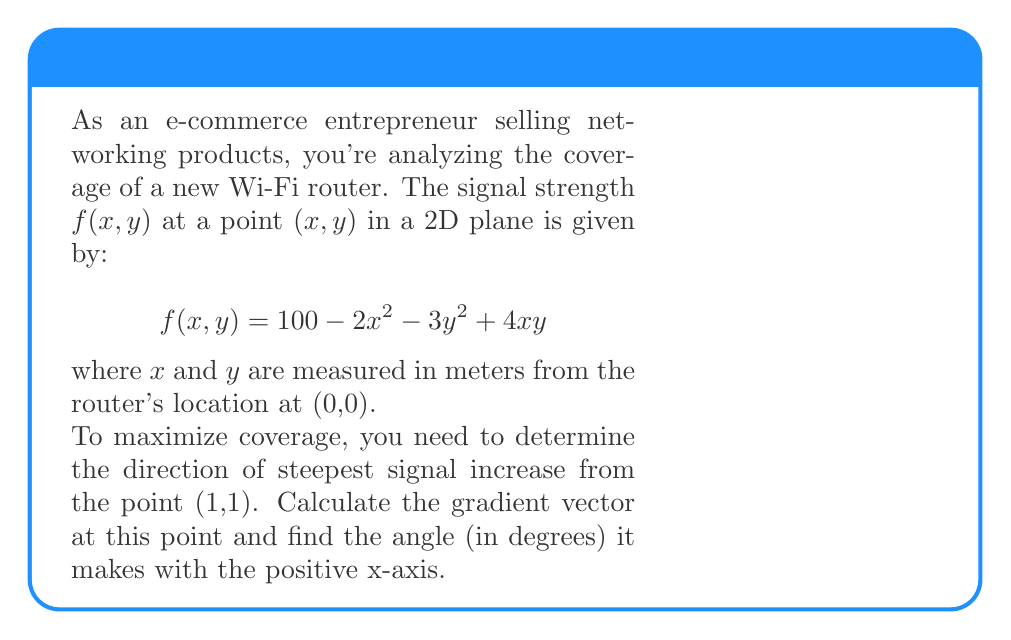Teach me how to tackle this problem. Let's approach this step-by-step:

1) The gradient vector is given by:
   $$\nabla f(x,y) = \left(\frac{\partial f}{\partial x}, \frac{\partial f}{\partial y}\right)$$

2) Calculate the partial derivatives:
   $$\frac{\partial f}{\partial x} = -4x + 4y$$
   $$\frac{\partial f}{\partial y} = -6y + 4x$$

3) The gradient vector at point (1,1) is:
   $$\nabla f(1,1) = (-4(1) + 4(1), -6(1) + 4(1)) = (0, -2)$$

4) To find the angle $\theta$ with the positive x-axis, we use the arctangent function:
   $$\theta = \arctan\left(\frac{y}{x}\right)$$

   Here, $x = 0$ and $y = -2$

5) Since $x = 0$, we're dealing with a vertical vector. The angle is:
   $$\theta = \arctan(\infty) = 90°$$

6) However, since the y-component is negative, we need to add 180° to get the correct direction:
   $$\theta = 90° + 180° = 270°$$

Therefore, the gradient vector points in the direction 270° from the positive x-axis, or equivalently, straight down.
Answer: 270° 